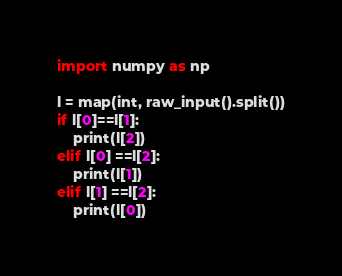<code> <loc_0><loc_0><loc_500><loc_500><_Python_>import numpy as np

l = map(int, raw_input().split())
if l[0]==l[1]:
	print(l[2])
elif l[0] ==l[2]:
	print(l[1])
elif l[1] ==l[2]:
	print(l[0])</code> 